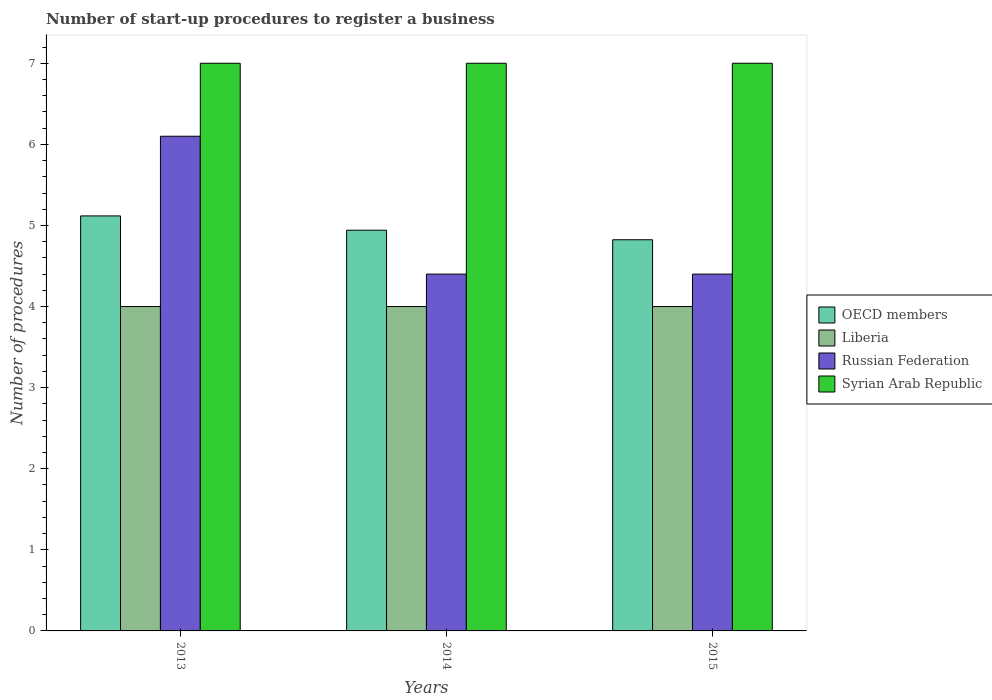Are the number of bars per tick equal to the number of legend labels?
Provide a short and direct response. Yes. Are the number of bars on each tick of the X-axis equal?
Your response must be concise. Yes. How many bars are there on the 2nd tick from the left?
Your answer should be very brief. 4. What is the label of the 3rd group of bars from the left?
Your answer should be compact. 2015. Across all years, what is the maximum number of procedures required to register a business in OECD members?
Ensure brevity in your answer.  5.12. In which year was the number of procedures required to register a business in Liberia minimum?
Ensure brevity in your answer.  2013. What is the total number of procedures required to register a business in OECD members in the graph?
Keep it short and to the point. 14.88. What is the difference between the number of procedures required to register a business in Russian Federation in 2015 and the number of procedures required to register a business in Liberia in 2014?
Keep it short and to the point. 0.4. What is the average number of procedures required to register a business in OECD members per year?
Provide a succinct answer. 4.96. In the year 2015, what is the difference between the number of procedures required to register a business in OECD members and number of procedures required to register a business in Liberia?
Make the answer very short. 0.82. In how many years, is the number of procedures required to register a business in Russian Federation greater than 3.2?
Offer a very short reply. 3. What is the ratio of the number of procedures required to register a business in OECD members in 2013 to that in 2014?
Provide a succinct answer. 1.04. Is the number of procedures required to register a business in OECD members in 2013 less than that in 2014?
Make the answer very short. No. What is the difference between the highest and the second highest number of procedures required to register a business in Syrian Arab Republic?
Provide a short and direct response. 0. Is the sum of the number of procedures required to register a business in Syrian Arab Republic in 2013 and 2015 greater than the maximum number of procedures required to register a business in OECD members across all years?
Provide a short and direct response. Yes. What does the 3rd bar from the left in 2014 represents?
Your answer should be very brief. Russian Federation. What does the 3rd bar from the right in 2013 represents?
Give a very brief answer. Liberia. Is it the case that in every year, the sum of the number of procedures required to register a business in Syrian Arab Republic and number of procedures required to register a business in OECD members is greater than the number of procedures required to register a business in Russian Federation?
Offer a terse response. Yes. Are all the bars in the graph horizontal?
Your answer should be very brief. No. What is the difference between two consecutive major ticks on the Y-axis?
Offer a terse response. 1. Does the graph contain any zero values?
Offer a terse response. No. How are the legend labels stacked?
Offer a very short reply. Vertical. What is the title of the graph?
Provide a short and direct response. Number of start-up procedures to register a business. Does "Channel Islands" appear as one of the legend labels in the graph?
Keep it short and to the point. No. What is the label or title of the X-axis?
Provide a short and direct response. Years. What is the label or title of the Y-axis?
Ensure brevity in your answer.  Number of procedures. What is the Number of procedures of OECD members in 2013?
Keep it short and to the point. 5.12. What is the Number of procedures in Russian Federation in 2013?
Make the answer very short. 6.1. What is the Number of procedures of OECD members in 2014?
Offer a very short reply. 4.94. What is the Number of procedures of Liberia in 2014?
Your response must be concise. 4. What is the Number of procedures in Syrian Arab Republic in 2014?
Keep it short and to the point. 7. What is the Number of procedures in OECD members in 2015?
Your response must be concise. 4.82. What is the Number of procedures in Liberia in 2015?
Ensure brevity in your answer.  4. What is the Number of procedures in Russian Federation in 2015?
Offer a terse response. 4.4. Across all years, what is the maximum Number of procedures in OECD members?
Keep it short and to the point. 5.12. Across all years, what is the maximum Number of procedures of Liberia?
Your answer should be compact. 4. Across all years, what is the maximum Number of procedures in Syrian Arab Republic?
Ensure brevity in your answer.  7. Across all years, what is the minimum Number of procedures in OECD members?
Make the answer very short. 4.82. Across all years, what is the minimum Number of procedures in Russian Federation?
Give a very brief answer. 4.4. Across all years, what is the minimum Number of procedures of Syrian Arab Republic?
Your answer should be compact. 7. What is the total Number of procedures in OECD members in the graph?
Offer a very short reply. 14.88. What is the total Number of procedures of Liberia in the graph?
Give a very brief answer. 12. What is the total Number of procedures of Russian Federation in the graph?
Provide a short and direct response. 14.9. What is the difference between the Number of procedures in OECD members in 2013 and that in 2014?
Provide a succinct answer. 0.18. What is the difference between the Number of procedures in Liberia in 2013 and that in 2014?
Offer a very short reply. 0. What is the difference between the Number of procedures in Russian Federation in 2013 and that in 2014?
Offer a terse response. 1.7. What is the difference between the Number of procedures in OECD members in 2013 and that in 2015?
Give a very brief answer. 0.29. What is the difference between the Number of procedures of Liberia in 2013 and that in 2015?
Offer a very short reply. 0. What is the difference between the Number of procedures of Russian Federation in 2013 and that in 2015?
Provide a short and direct response. 1.7. What is the difference between the Number of procedures in Syrian Arab Republic in 2013 and that in 2015?
Your response must be concise. 0. What is the difference between the Number of procedures in OECD members in 2014 and that in 2015?
Offer a very short reply. 0.12. What is the difference between the Number of procedures in Syrian Arab Republic in 2014 and that in 2015?
Keep it short and to the point. 0. What is the difference between the Number of procedures of OECD members in 2013 and the Number of procedures of Liberia in 2014?
Provide a short and direct response. 1.12. What is the difference between the Number of procedures in OECD members in 2013 and the Number of procedures in Russian Federation in 2014?
Make the answer very short. 0.72. What is the difference between the Number of procedures of OECD members in 2013 and the Number of procedures of Syrian Arab Republic in 2014?
Your response must be concise. -1.88. What is the difference between the Number of procedures in Liberia in 2013 and the Number of procedures in Syrian Arab Republic in 2014?
Keep it short and to the point. -3. What is the difference between the Number of procedures of Russian Federation in 2013 and the Number of procedures of Syrian Arab Republic in 2014?
Give a very brief answer. -0.9. What is the difference between the Number of procedures in OECD members in 2013 and the Number of procedures in Liberia in 2015?
Make the answer very short. 1.12. What is the difference between the Number of procedures of OECD members in 2013 and the Number of procedures of Russian Federation in 2015?
Ensure brevity in your answer.  0.72. What is the difference between the Number of procedures of OECD members in 2013 and the Number of procedures of Syrian Arab Republic in 2015?
Offer a very short reply. -1.88. What is the difference between the Number of procedures in Liberia in 2013 and the Number of procedures in Russian Federation in 2015?
Provide a short and direct response. -0.4. What is the difference between the Number of procedures of Liberia in 2013 and the Number of procedures of Syrian Arab Republic in 2015?
Your answer should be compact. -3. What is the difference between the Number of procedures in Russian Federation in 2013 and the Number of procedures in Syrian Arab Republic in 2015?
Provide a succinct answer. -0.9. What is the difference between the Number of procedures of OECD members in 2014 and the Number of procedures of Liberia in 2015?
Make the answer very short. 0.94. What is the difference between the Number of procedures of OECD members in 2014 and the Number of procedures of Russian Federation in 2015?
Your answer should be compact. 0.54. What is the difference between the Number of procedures of OECD members in 2014 and the Number of procedures of Syrian Arab Republic in 2015?
Give a very brief answer. -2.06. What is the difference between the Number of procedures in Liberia in 2014 and the Number of procedures in Russian Federation in 2015?
Ensure brevity in your answer.  -0.4. What is the difference between the Number of procedures of Russian Federation in 2014 and the Number of procedures of Syrian Arab Republic in 2015?
Offer a very short reply. -2.6. What is the average Number of procedures in OECD members per year?
Your answer should be very brief. 4.96. What is the average Number of procedures of Liberia per year?
Your answer should be very brief. 4. What is the average Number of procedures in Russian Federation per year?
Make the answer very short. 4.97. What is the average Number of procedures of Syrian Arab Republic per year?
Give a very brief answer. 7. In the year 2013, what is the difference between the Number of procedures of OECD members and Number of procedures of Liberia?
Offer a very short reply. 1.12. In the year 2013, what is the difference between the Number of procedures in OECD members and Number of procedures in Russian Federation?
Ensure brevity in your answer.  -0.98. In the year 2013, what is the difference between the Number of procedures in OECD members and Number of procedures in Syrian Arab Republic?
Ensure brevity in your answer.  -1.88. In the year 2013, what is the difference between the Number of procedures of Liberia and Number of procedures of Russian Federation?
Ensure brevity in your answer.  -2.1. In the year 2013, what is the difference between the Number of procedures in Liberia and Number of procedures in Syrian Arab Republic?
Offer a terse response. -3. In the year 2014, what is the difference between the Number of procedures in OECD members and Number of procedures in Liberia?
Provide a short and direct response. 0.94. In the year 2014, what is the difference between the Number of procedures of OECD members and Number of procedures of Russian Federation?
Give a very brief answer. 0.54. In the year 2014, what is the difference between the Number of procedures in OECD members and Number of procedures in Syrian Arab Republic?
Offer a terse response. -2.06. In the year 2014, what is the difference between the Number of procedures of Liberia and Number of procedures of Russian Federation?
Your answer should be very brief. -0.4. In the year 2015, what is the difference between the Number of procedures of OECD members and Number of procedures of Liberia?
Keep it short and to the point. 0.82. In the year 2015, what is the difference between the Number of procedures of OECD members and Number of procedures of Russian Federation?
Your answer should be compact. 0.42. In the year 2015, what is the difference between the Number of procedures of OECD members and Number of procedures of Syrian Arab Republic?
Make the answer very short. -2.18. In the year 2015, what is the difference between the Number of procedures in Liberia and Number of procedures in Russian Federation?
Your response must be concise. -0.4. In the year 2015, what is the difference between the Number of procedures in Liberia and Number of procedures in Syrian Arab Republic?
Keep it short and to the point. -3. What is the ratio of the Number of procedures in OECD members in 2013 to that in 2014?
Offer a very short reply. 1.04. What is the ratio of the Number of procedures of Liberia in 2013 to that in 2014?
Provide a succinct answer. 1. What is the ratio of the Number of procedures of Russian Federation in 2013 to that in 2014?
Make the answer very short. 1.39. What is the ratio of the Number of procedures of Syrian Arab Republic in 2013 to that in 2014?
Ensure brevity in your answer.  1. What is the ratio of the Number of procedures of OECD members in 2013 to that in 2015?
Offer a very short reply. 1.06. What is the ratio of the Number of procedures of Russian Federation in 2013 to that in 2015?
Make the answer very short. 1.39. What is the ratio of the Number of procedures in Syrian Arab Republic in 2013 to that in 2015?
Offer a very short reply. 1. What is the ratio of the Number of procedures in OECD members in 2014 to that in 2015?
Your answer should be very brief. 1.02. What is the ratio of the Number of procedures in Liberia in 2014 to that in 2015?
Your response must be concise. 1. What is the ratio of the Number of procedures in Syrian Arab Republic in 2014 to that in 2015?
Ensure brevity in your answer.  1. What is the difference between the highest and the second highest Number of procedures of OECD members?
Give a very brief answer. 0.18. What is the difference between the highest and the second highest Number of procedures of Syrian Arab Republic?
Your answer should be compact. 0. What is the difference between the highest and the lowest Number of procedures in OECD members?
Your response must be concise. 0.29. What is the difference between the highest and the lowest Number of procedures in Syrian Arab Republic?
Offer a very short reply. 0. 